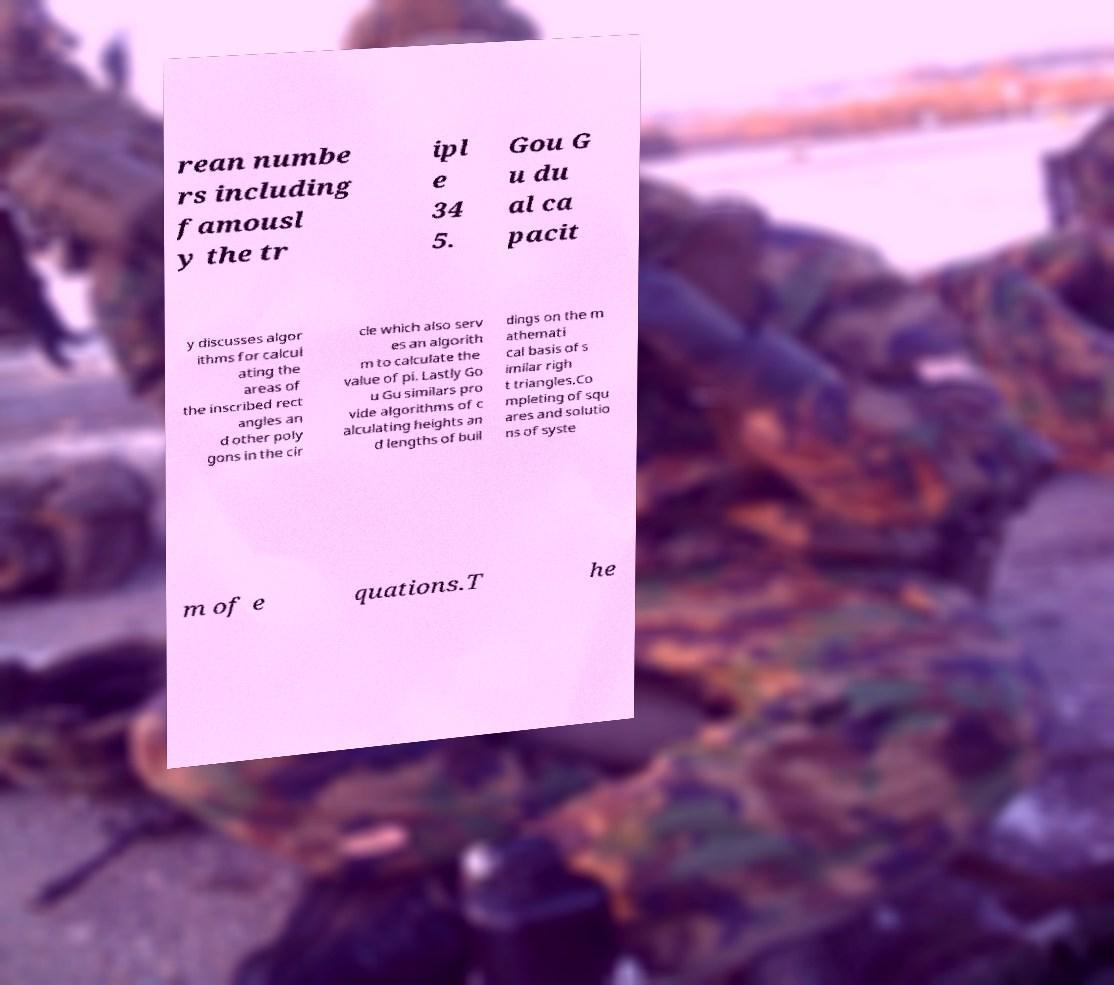For documentation purposes, I need the text within this image transcribed. Could you provide that? rean numbe rs including famousl y the tr ipl e 34 5. Gou G u du al ca pacit y discusses algor ithms for calcul ating the areas of the inscribed rect angles an d other poly gons in the cir cle which also serv es an algorith m to calculate the value of pi. Lastly Go u Gu similars pro vide algorithms of c alculating heights an d lengths of buil dings on the m athemati cal basis of s imilar righ t triangles.Co mpleting of squ ares and solutio ns of syste m of e quations.T he 